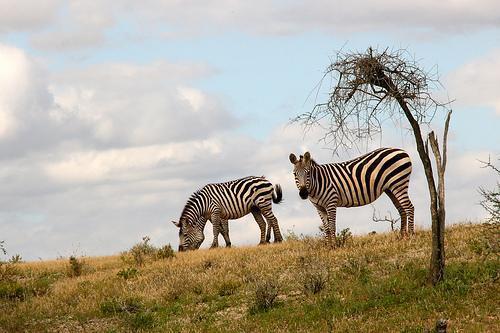How many zebras are there?
Give a very brief answer. 2. 